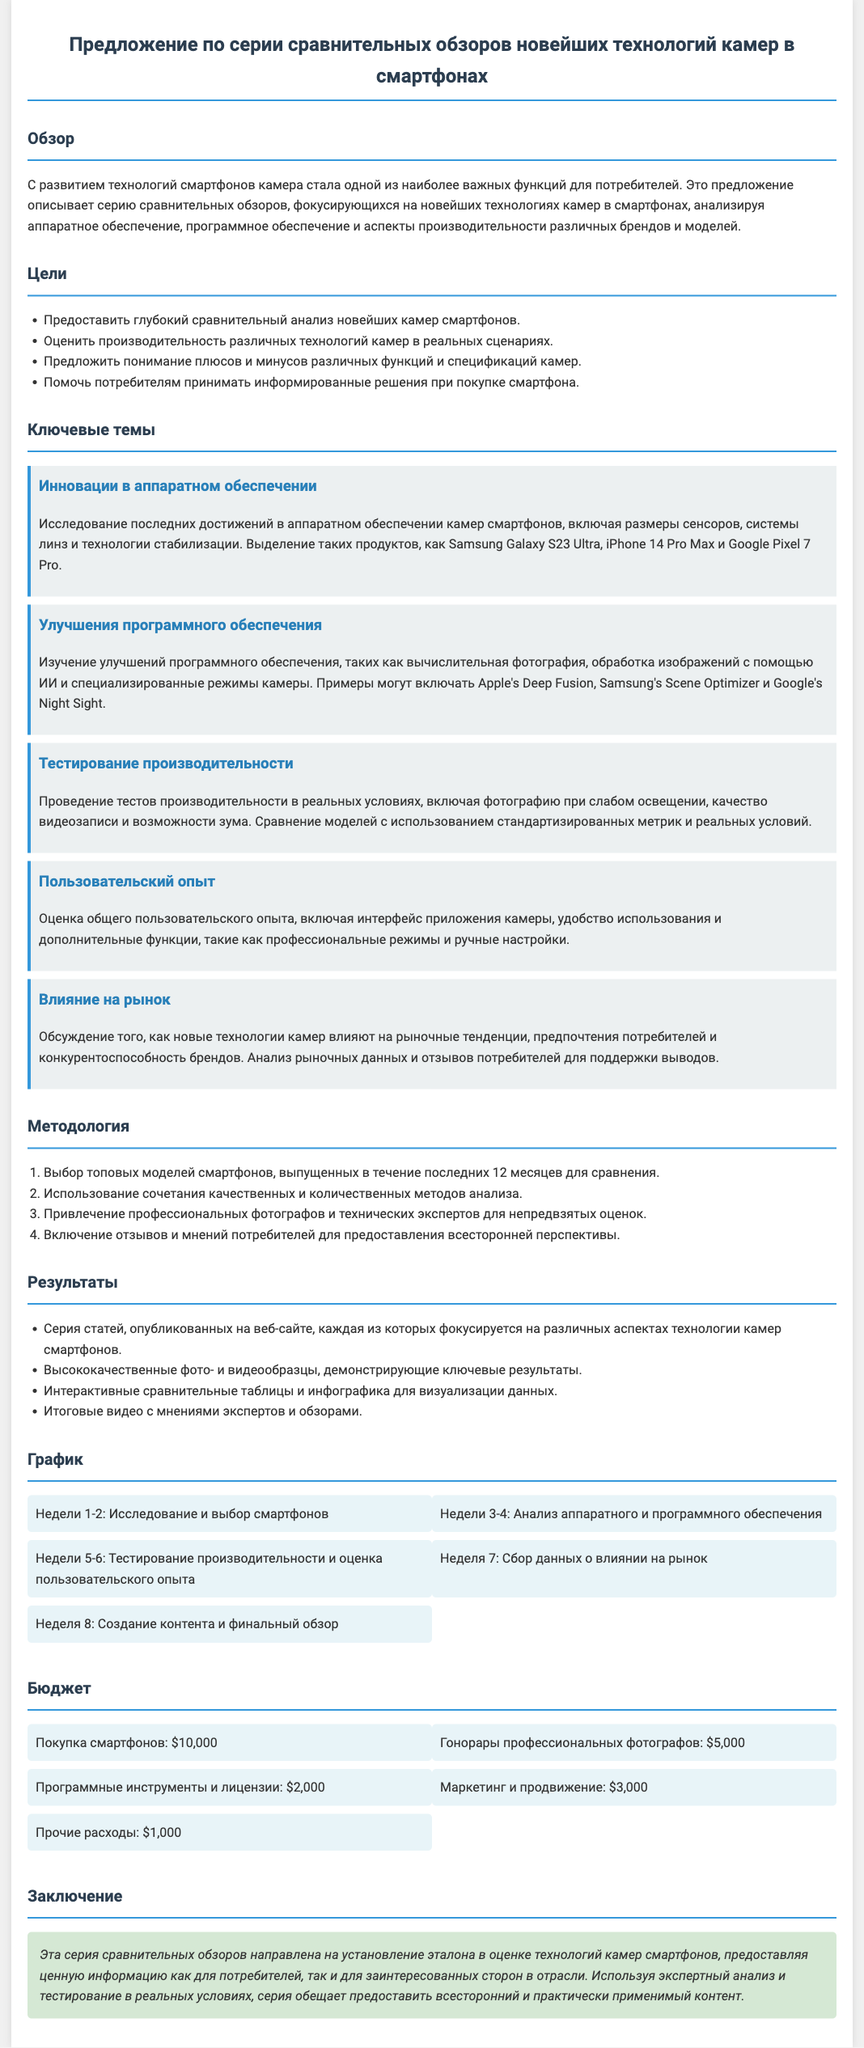Что является основной целью данного предложения? Основная цель предложения описана в разделе "Цели", где указано, что необходимо предоставить глубокий сравнительный анализ новейших камер смартфонов.
Answer: Глубокий сравнительный анализ новейших камер смартфонов Какой смартфон упоминается как один из примеров инноваций в аппаратном обеспечении? В разделе "Инновации в аппаратном обеспечении" упоминается Samsung Galaxy S23 Ultra как пример новейшей технологии.
Answer: Samsung Galaxy S23 Ultra Сколько недель запланировано на исследование и выбор смартфонов? В разделе "График" указано, что на исследование и выбор смартфонов запланировано 2 недели.
Answer: 2 недели Какова общая сумма бюджета на проект? В разделе "Бюджет" перечислены различные статьи расходов, которые в сумме составляют 21,000 долларов.
Answer: $21,000 Какая методология будет использована для анализа? В разделе "Методология" сказано о сочетании качественных и количественных методов для анализа, а также привлечение экспертов.
Answer: Сочетание качественных и количественных методов анализа 